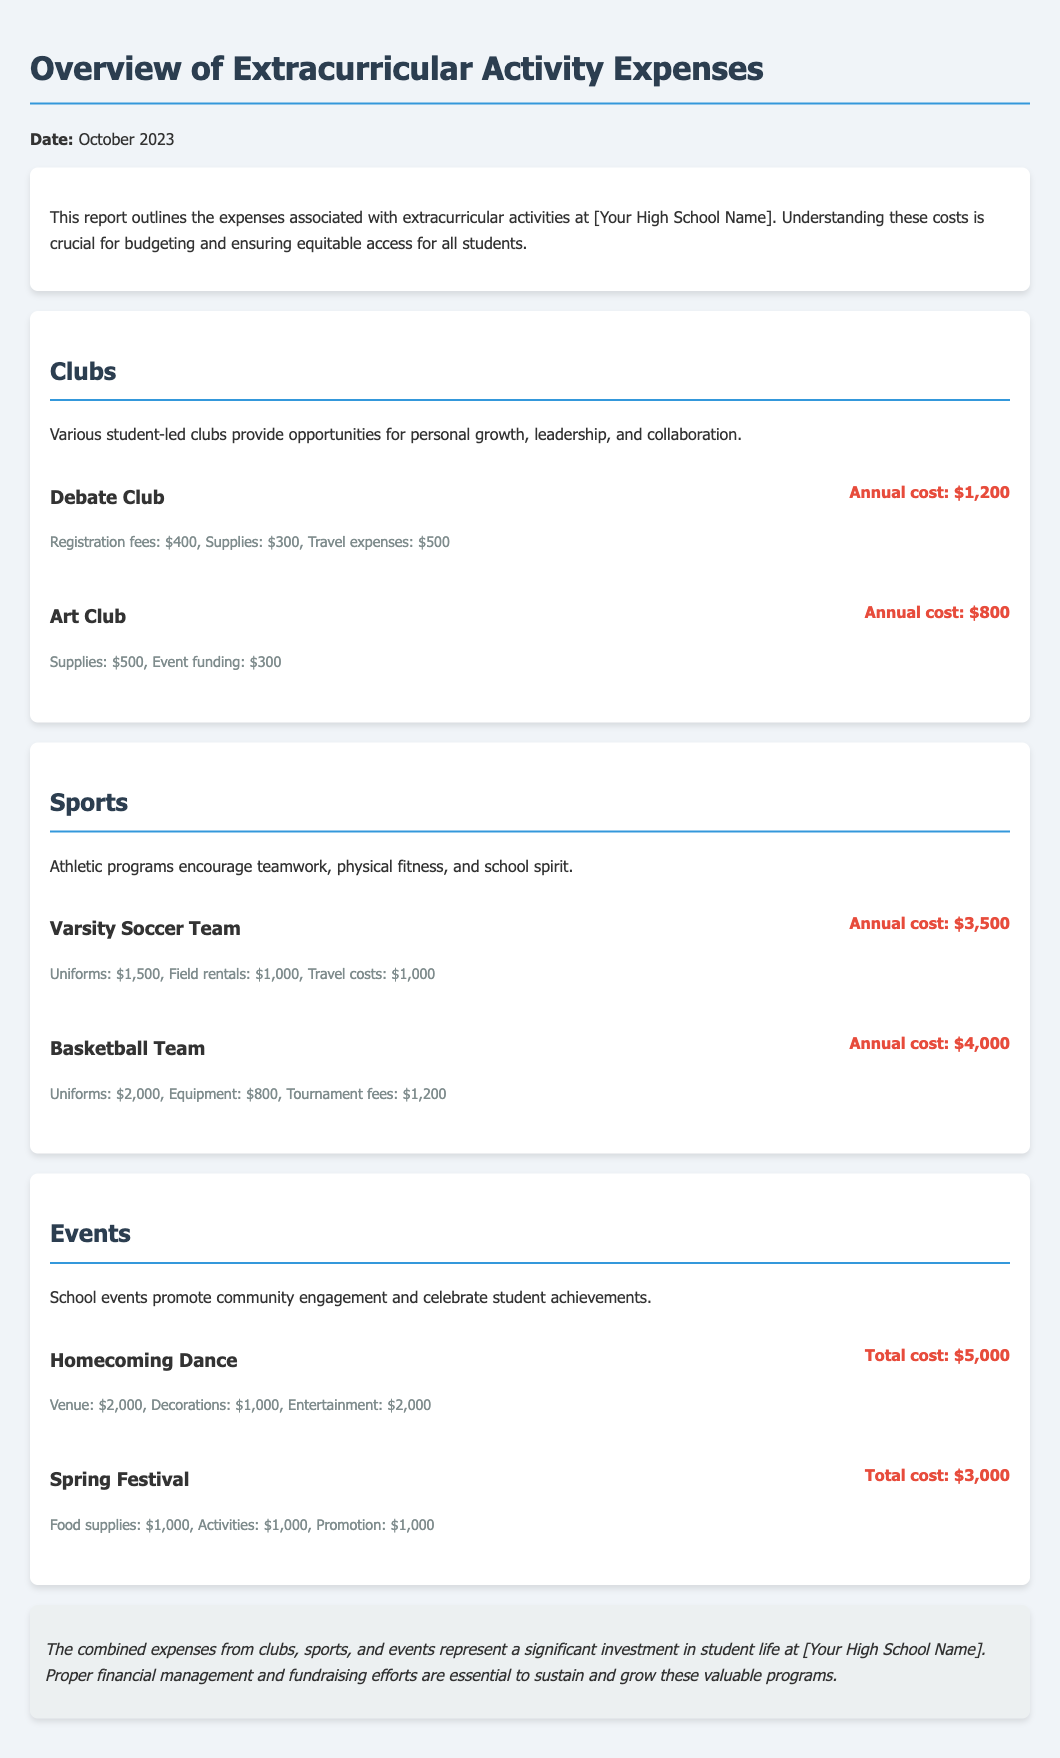What is the total annual cost for the Debate Club? The annual cost for the Debate Club is outlined in the document, which specifies it as $1,200.
Answer: $1,200 What are the supplies costs for the Art Club? The document indicates that the supplies cost for the Art Club is $500.
Answer: $500 How much is spent on uniforms for the Varsity Soccer Team? The document states that the uniforms cost for the Varsity Soccer Team is $1,500.
Answer: $1,500 What is the total cost of the Homecoming Dance? The document reveals that the total cost for the Homecoming Dance is $5,000.
Answer: $5,000 Which sport has a higher total cost, Basketball Team or Varsity Soccer Team? By comparing the total costs, the Basketball Team's total cost is $4,000, while the Varsity Soccer Team's total cost is $3,500. Thus, the Basketball Team has a higher cost.
Answer: Basketball Team What is the total amount spent on field rentals for sports? The document shows that field rentals for the Varsity Soccer Team cost $1,000, which is the only field rental expense listed.
Answer: $1,000 Which event has the highest cost listed in the report? The Homecoming Dance has the highest listed cost at $5,000 compared to the Spring Festival which costs $3,000.
Answer: Homecoming Dance What are the total supplies costs for the Spring Festival? The total supplies costs for the Spring Festival is mentioned as $1,000 for food supplies, $1,000 for activities, and $1,000 for promotion, which sums up to $3,000. However, the document more directly refers to event costs instead of simply supplies.
Answer: $3,000 How much is allocated for travel expenses in the Debate Club? The travel expenses for the Debate Club are specified as $500 in the document.
Answer: $500 